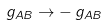<formula> <loc_0><loc_0><loc_500><loc_500>g _ { A B } \rightarrow - \, g _ { A B }</formula> 